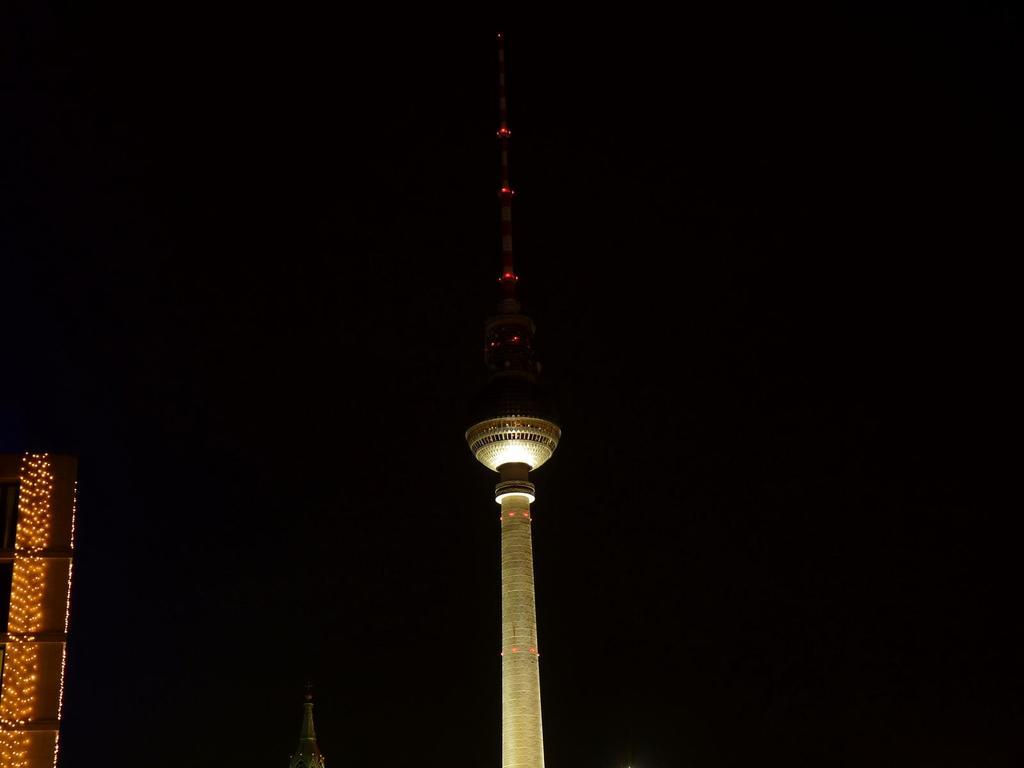What type of structure is present in the image? There is a building in the image. Can you describe the color of the building? The building is cream-colored. Where are the lights located in the image? The lights are visible on the left side of the image. What is the color of the background in the image? The background of the image is black. What type of drink is being served by the maid in the image? There is no maid or drink present in the image; it only features a building with lights and a black background. 